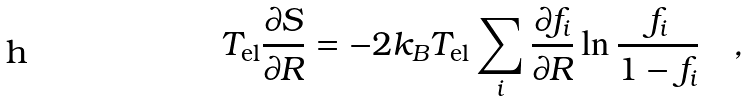<formula> <loc_0><loc_0><loc_500><loc_500>T _ { \text {el} } \frac { \partial S } { \partial { R } } = - 2 k _ { B } T _ { \text {el} } \sum _ { i } \frac { \partial f _ { i } } { \partial { R } } \ln \frac { f _ { i } } { 1 - f _ { i } } \quad ,</formula> 